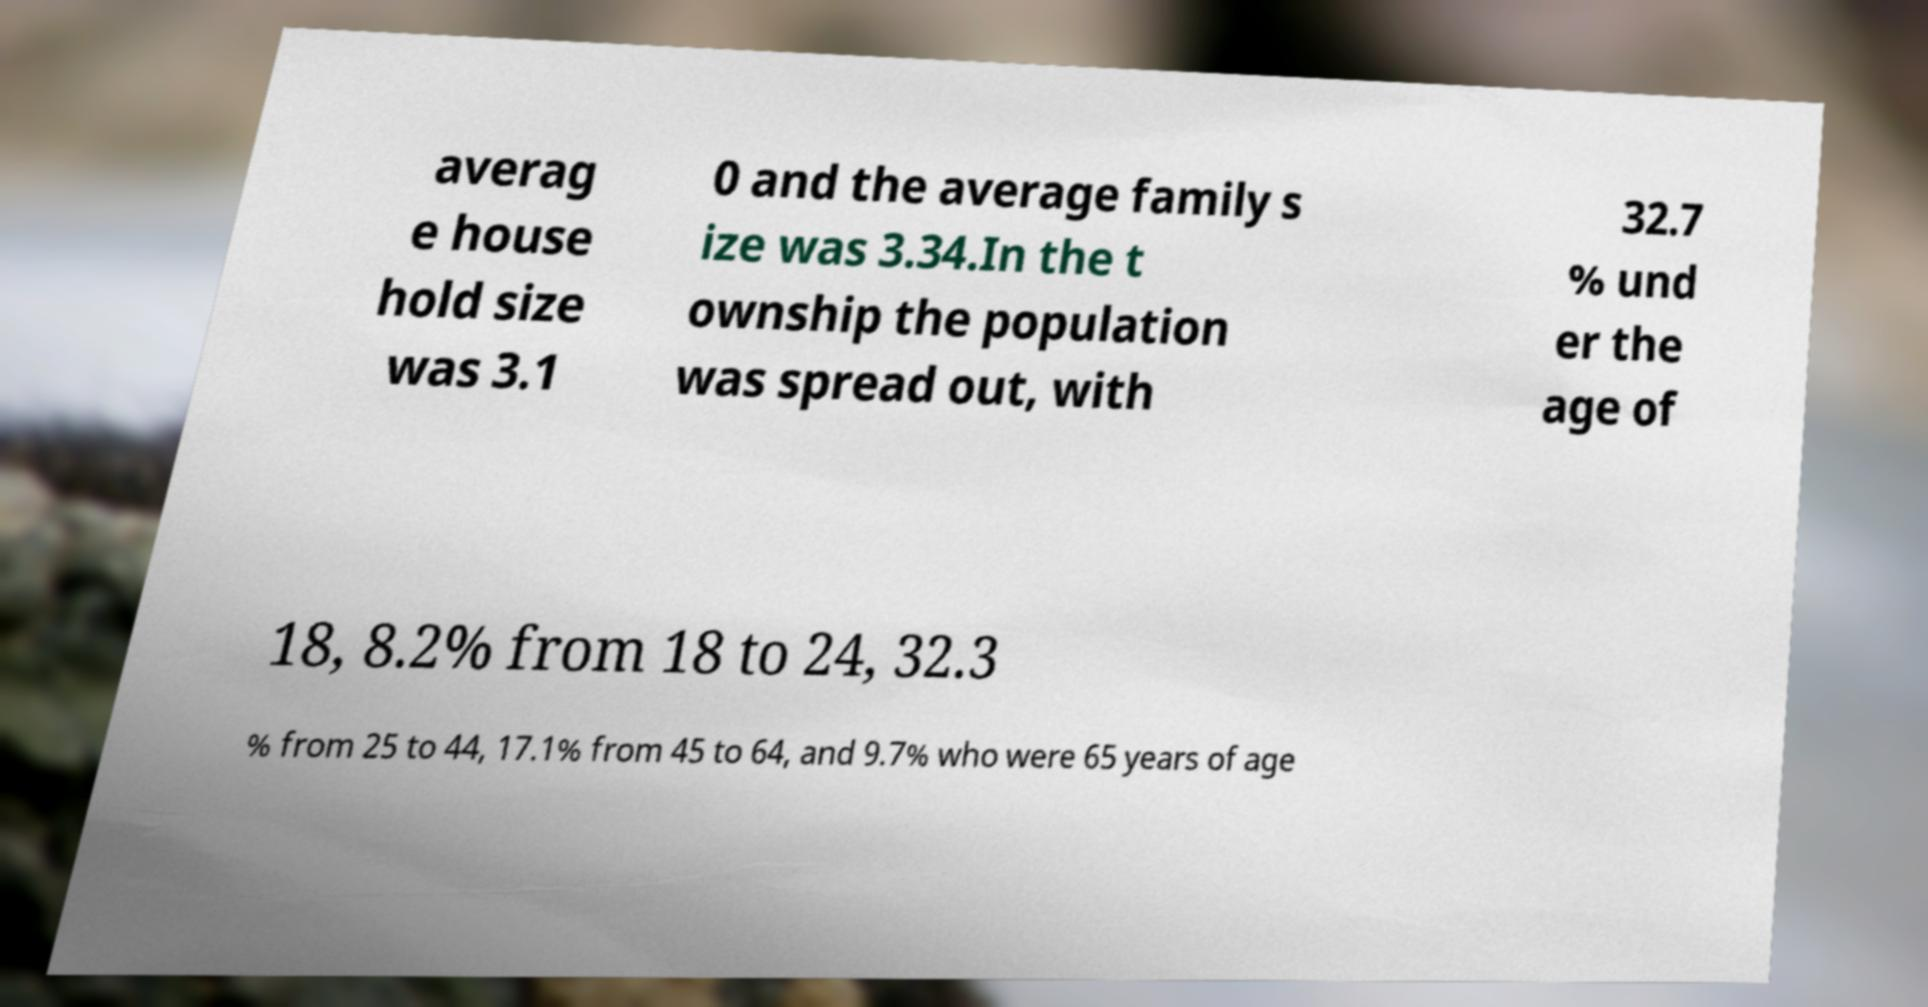Please identify and transcribe the text found in this image. averag e house hold size was 3.1 0 and the average family s ize was 3.34.In the t ownship the population was spread out, with 32.7 % und er the age of 18, 8.2% from 18 to 24, 32.3 % from 25 to 44, 17.1% from 45 to 64, and 9.7% who were 65 years of age 